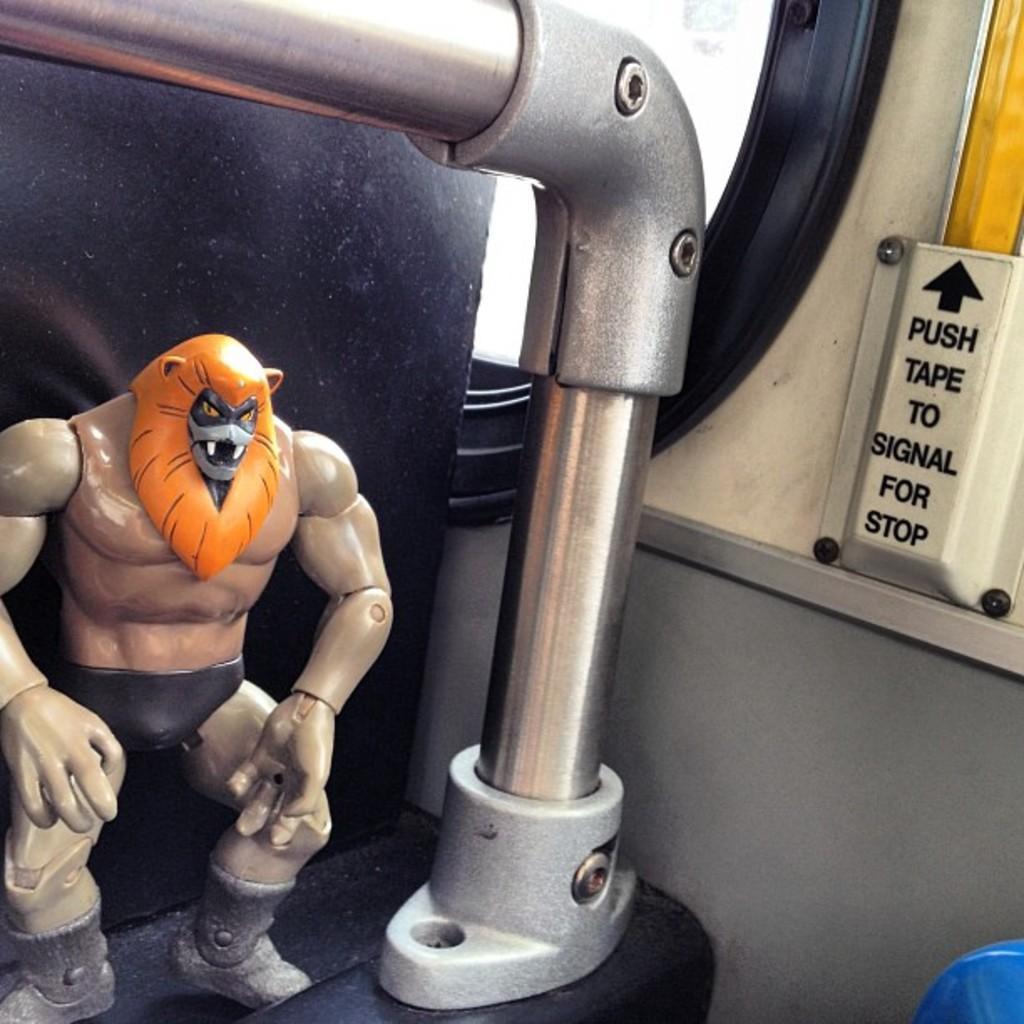How would you summarize this image in a sentence or two? In this image in the front there is a toy which is on the black colour surface and in the center there is a pipe. On the right side there is a button with some text written on it and in the background there is a window. 